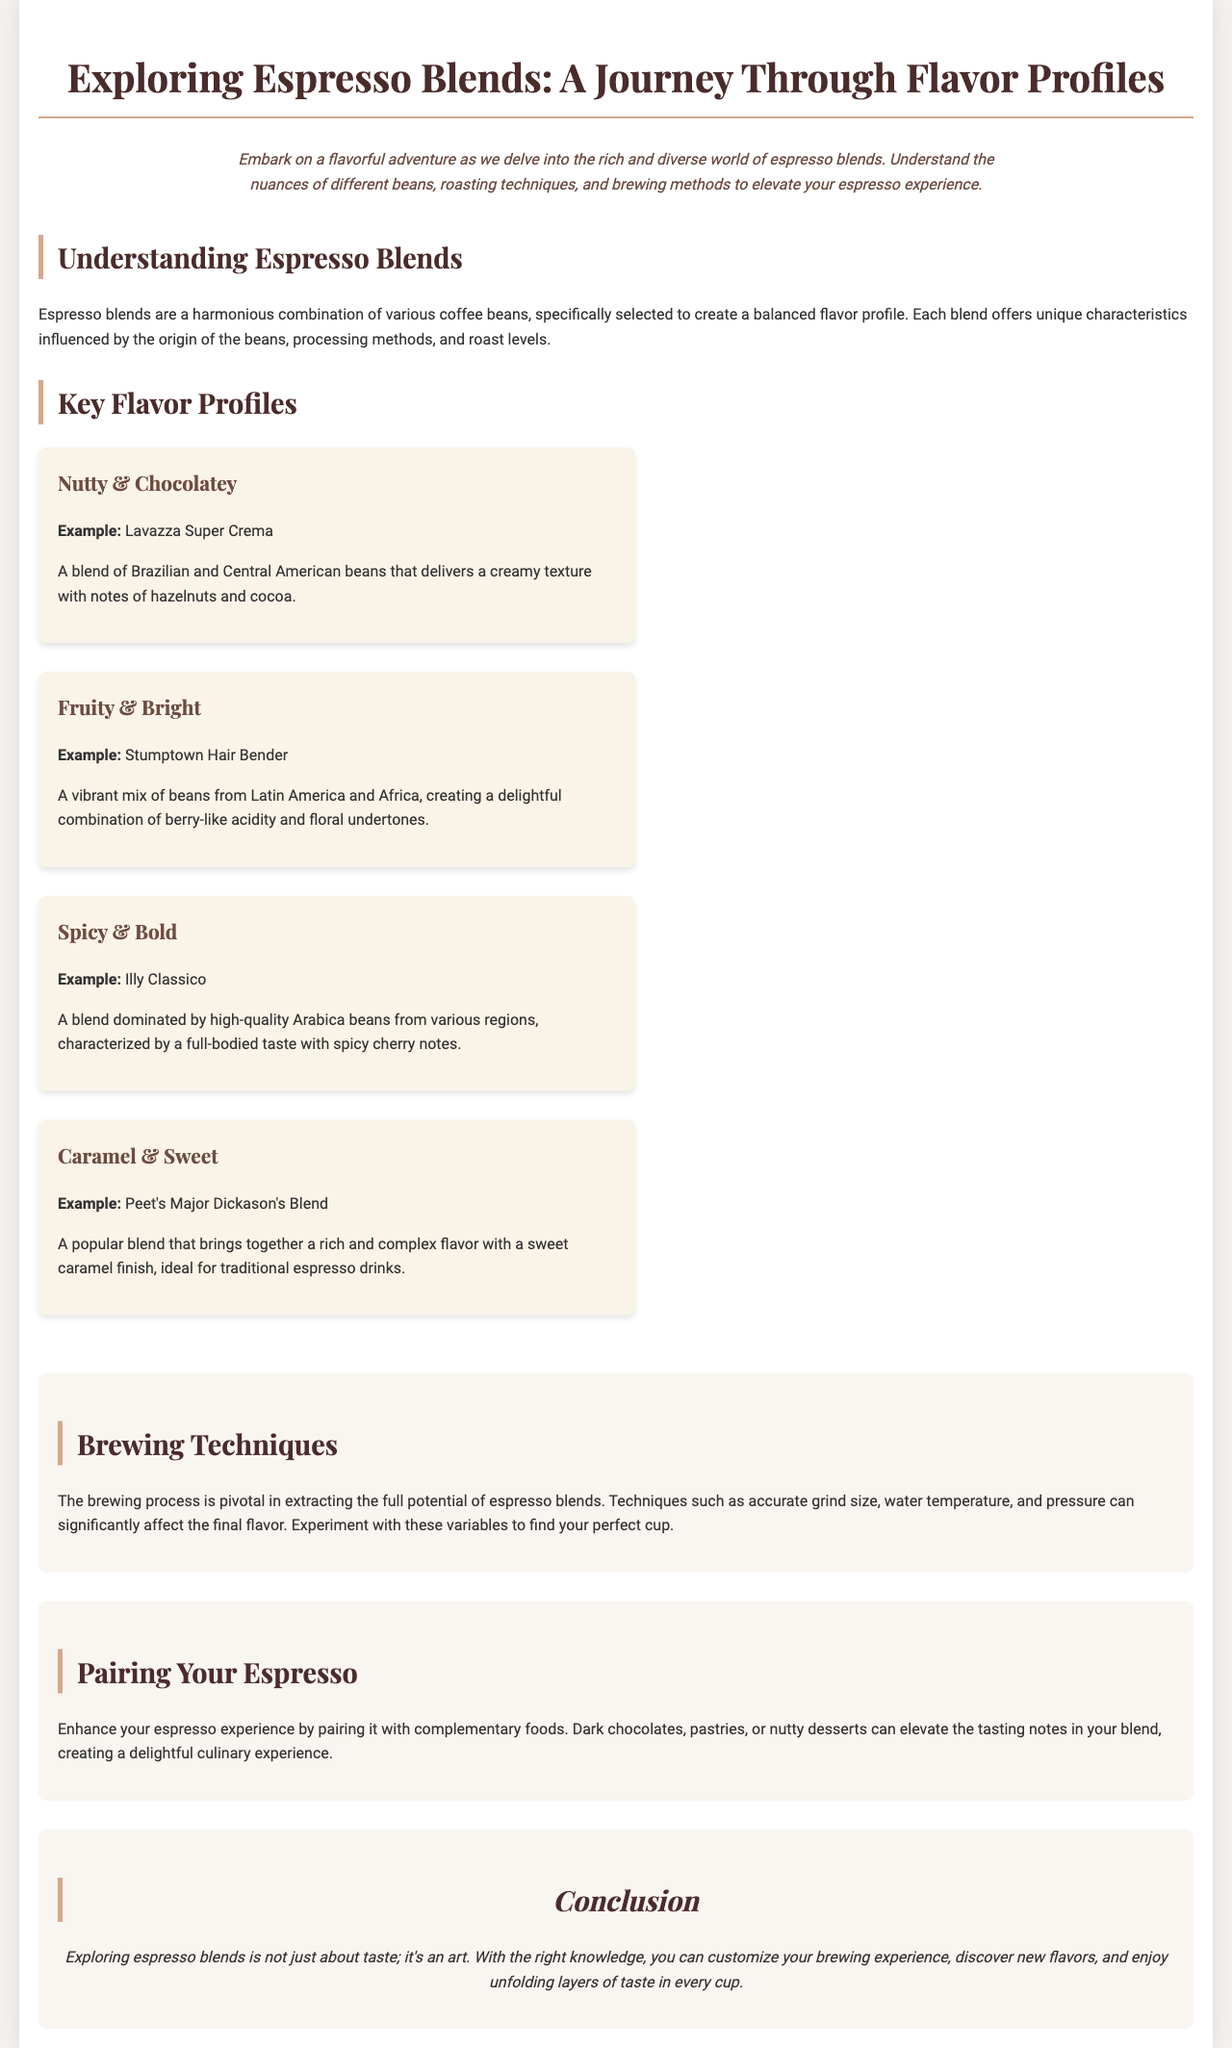What is the title of the brochure? The title of the brochure is found at the top of the document, indicating the main subject discussed.
Answer: Exploring Espresso Blends: A Journey Through Flavor Profiles What are the examples of the Nutty & Chocolatey flavor profile? The specific example providing insight into this flavor profile is included in the description section.
Answer: Lavazza Super Crema Which flavor profile is characterized by a full-bodied taste? This question looks for the flavor profile with specific traits, mentioned in the Key Flavor Profiles section.
Answer: Spicy & Bold How many flavor profiles are detailed in the brochure? The number of distinct flavor profiles presented is outlined within the Key Flavor Profiles section.
Answer: Four What two regions contribute to the Fruity & Bright profile? This question combines information from different sections to identify the bean origins that influence that profile.
Answer: Latin America and Africa What is the concluding statement's focus? This question refers to the conclusion's content, summarizing the essence of espresso blends.
Answer: It's an art Name one food recommended for pairing with espresso. This question seeks specific pairing suggestions offered in the Pairing Your Espresso section.
Answer: Dark chocolates Which espresso blend is mentioned for its sweet caramel finish? The question seeks to identify the specific blend related to the described taste characteristics.
Answer: Peet's Major Dickason's Blend What brewing factors can affect espresso flavor? This question combines information regarding the brewing process and its importance covered in the document.
Answer: Grind size, water temperature, and pressure 